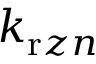<formula> <loc_0><loc_0><loc_500><loc_500>k _ { r z n }</formula> 